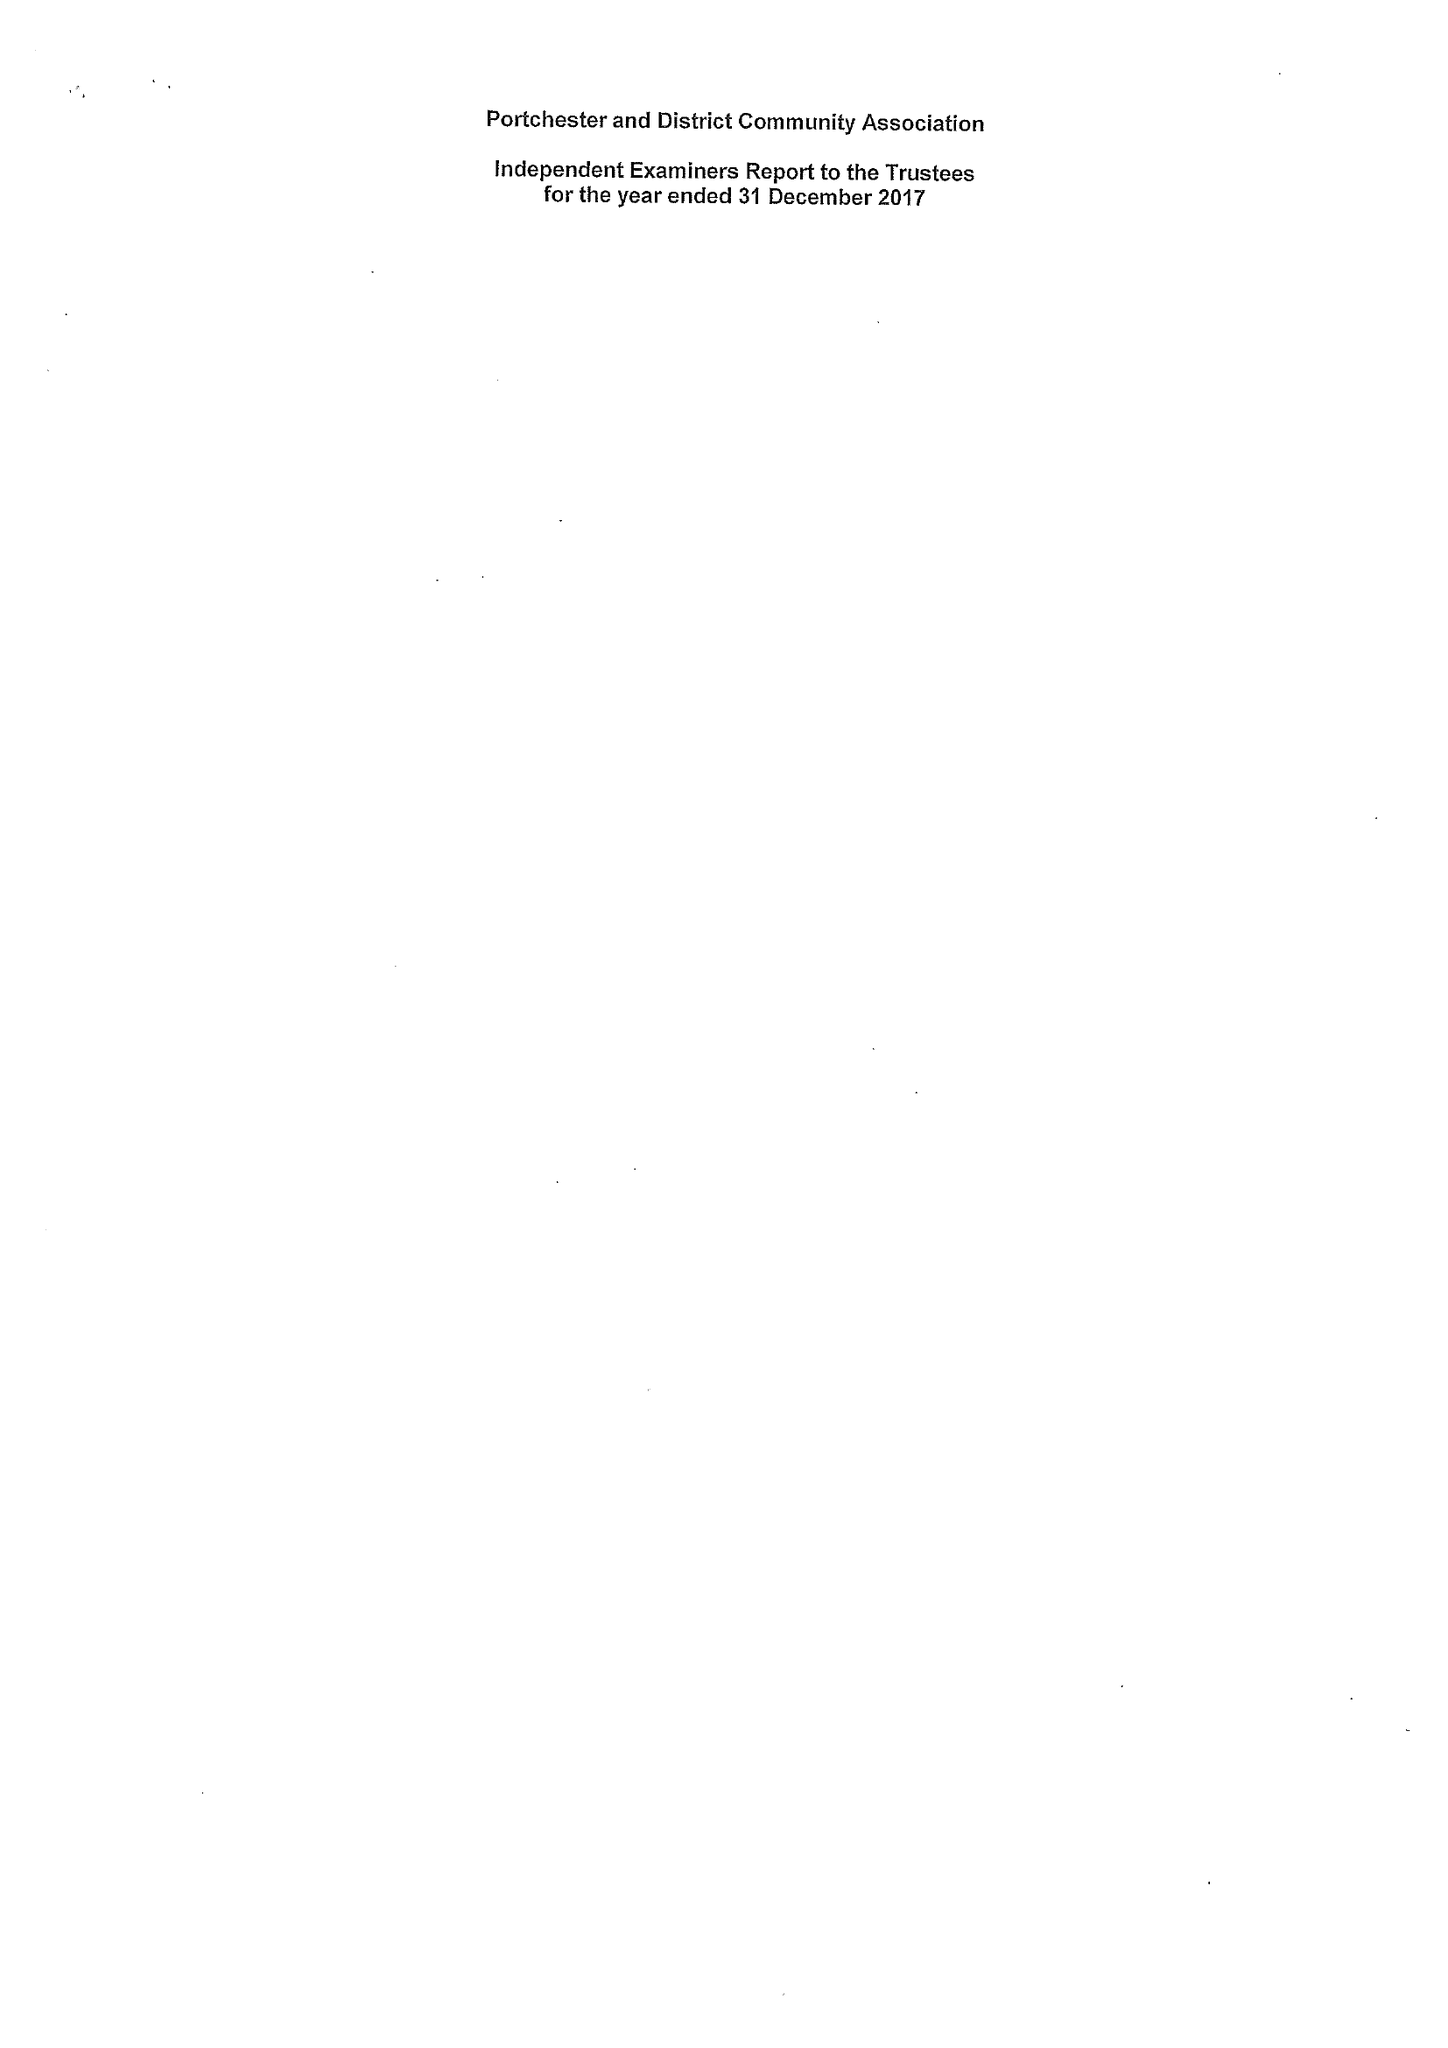What is the value for the charity_name?
Answer the question using a single word or phrase. Portchester and District Community Association CIO 